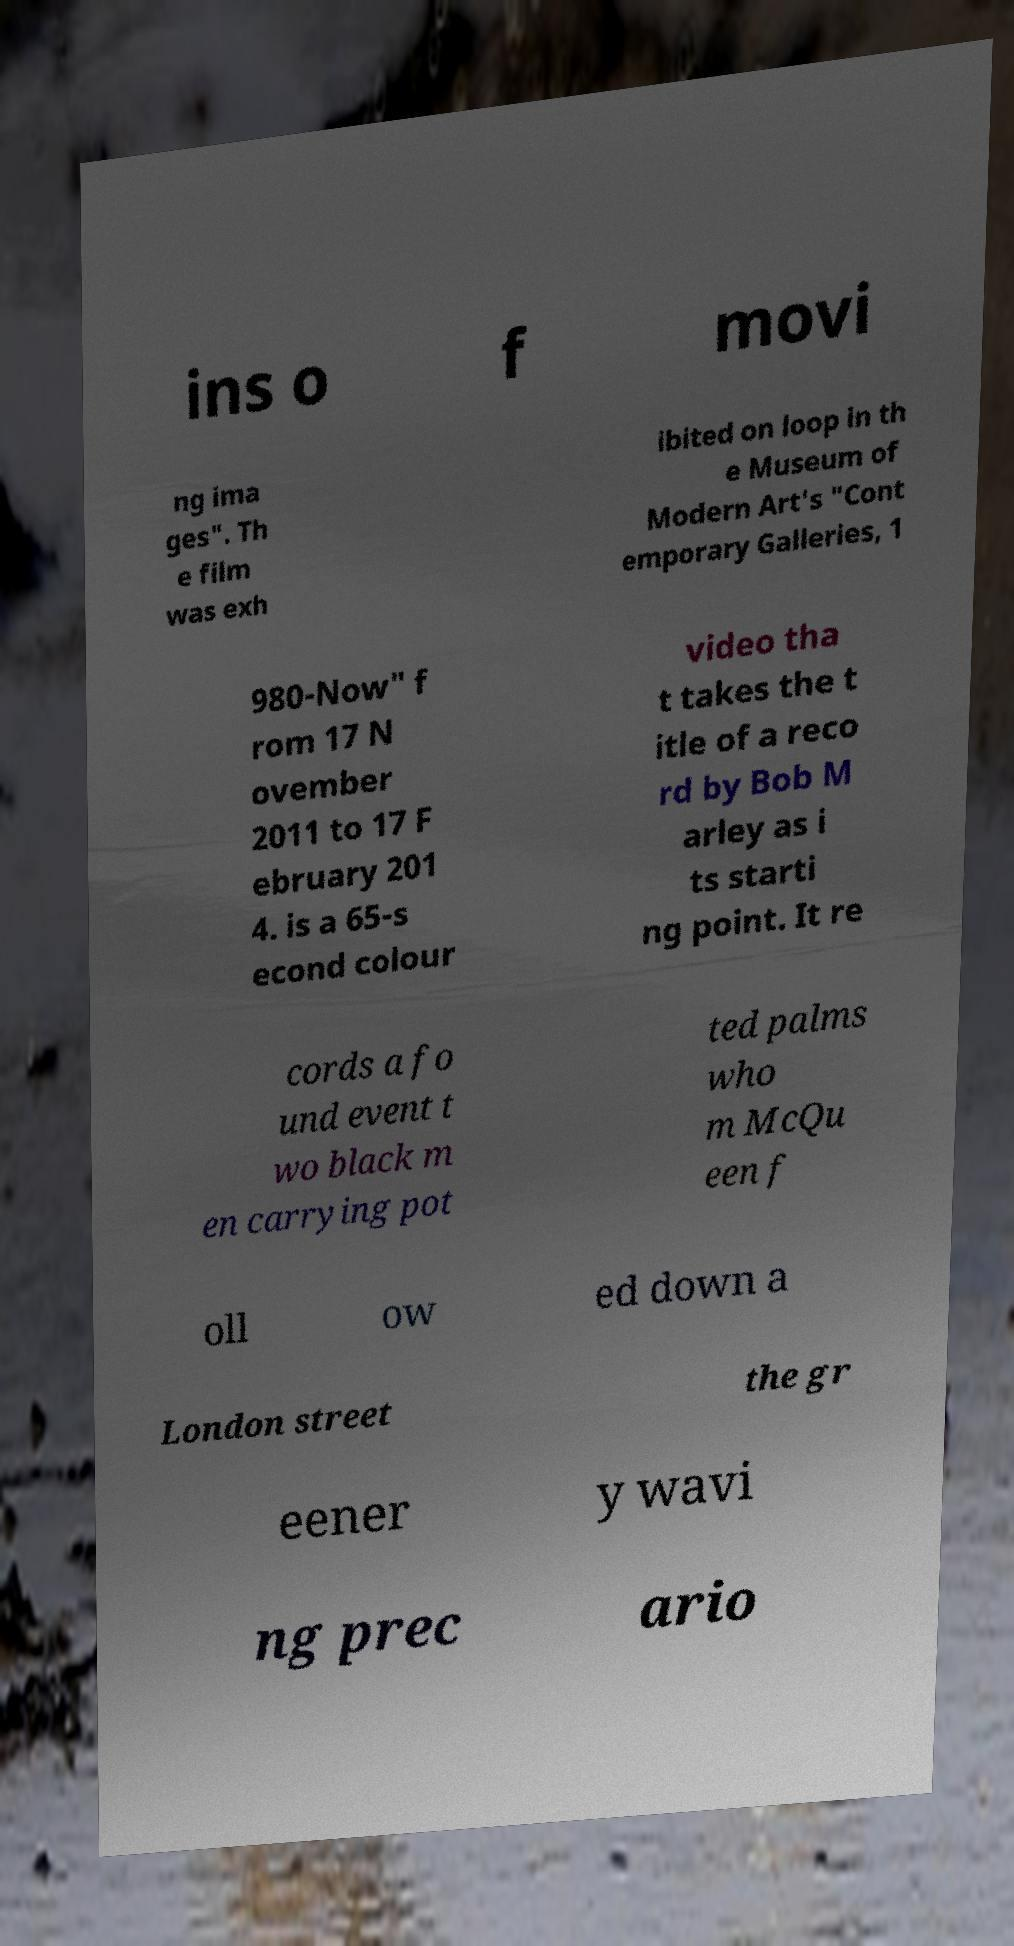Can you read and provide the text displayed in the image?This photo seems to have some interesting text. Can you extract and type it out for me? ins o f movi ng ima ges". Th e film was exh ibited on loop in th e Museum of Modern Art's "Cont emporary Galleries, 1 980-Now" f rom 17 N ovember 2011 to 17 F ebruary 201 4. is a 65-s econd colour video tha t takes the t itle of a reco rd by Bob M arley as i ts starti ng point. It re cords a fo und event t wo black m en carrying pot ted palms who m McQu een f oll ow ed down a London street the gr eener y wavi ng prec ario 